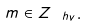Convert formula to latex. <formula><loc_0><loc_0><loc_500><loc_500>m \in Z _ { \, \ h v } .</formula> 